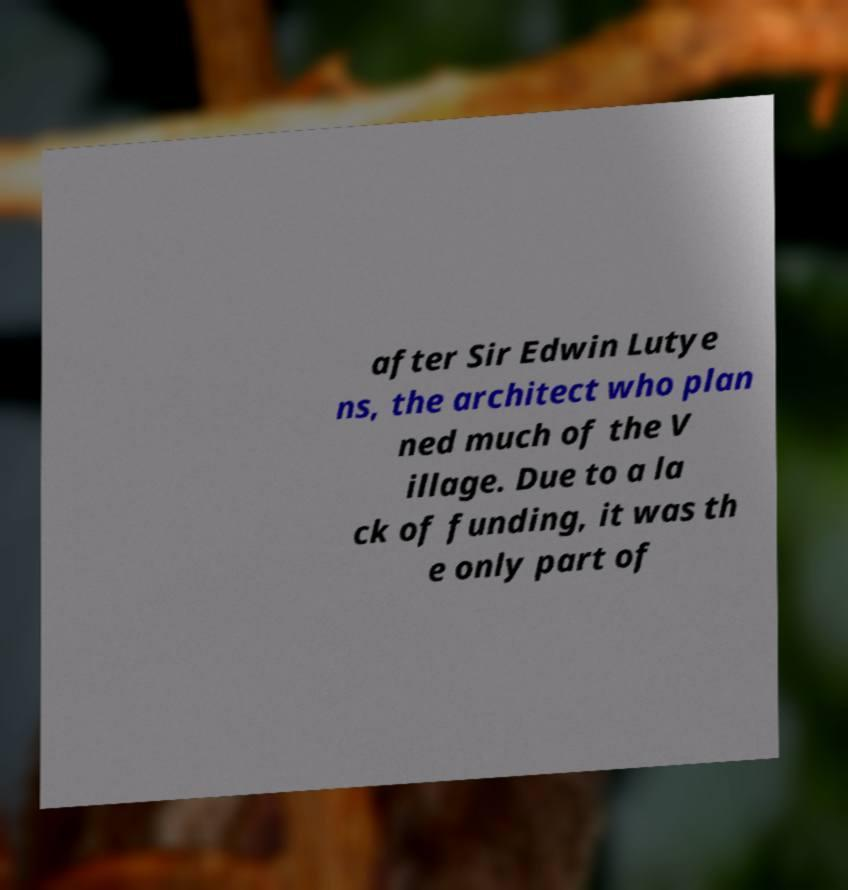For documentation purposes, I need the text within this image transcribed. Could you provide that? after Sir Edwin Lutye ns, the architect who plan ned much of the V illage. Due to a la ck of funding, it was th e only part of 